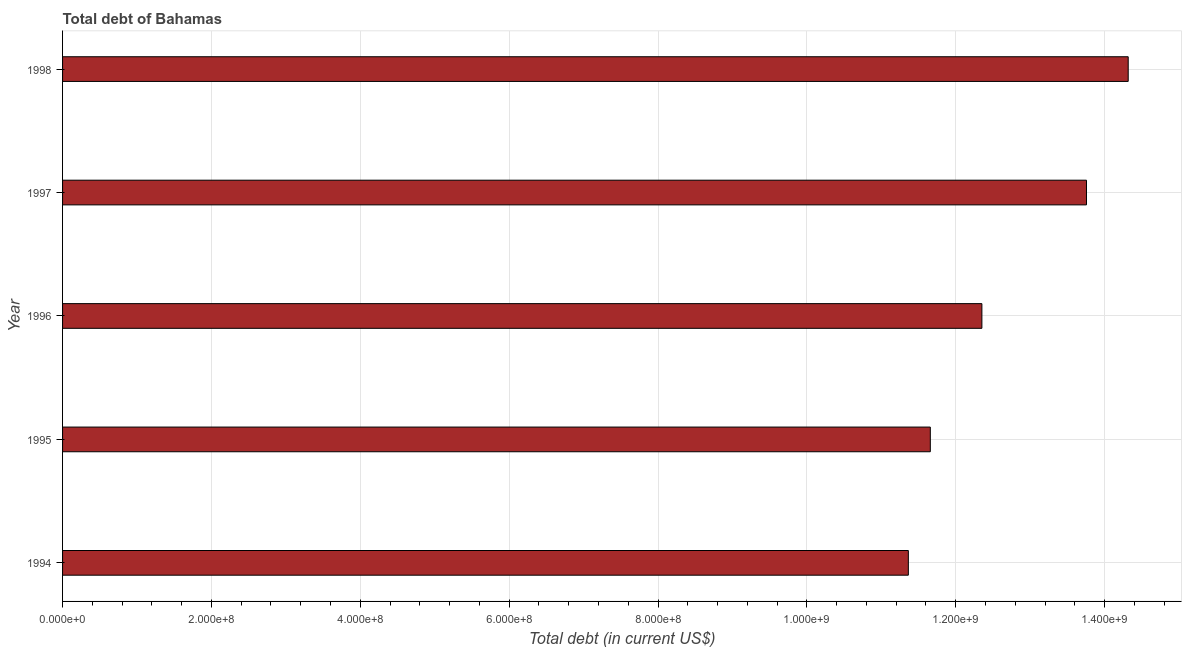What is the title of the graph?
Your response must be concise. Total debt of Bahamas. What is the label or title of the X-axis?
Offer a very short reply. Total debt (in current US$). What is the total debt in 1995?
Make the answer very short. 1.17e+09. Across all years, what is the maximum total debt?
Your answer should be compact. 1.43e+09. Across all years, what is the minimum total debt?
Provide a short and direct response. 1.14e+09. What is the sum of the total debt?
Make the answer very short. 6.34e+09. What is the difference between the total debt in 1994 and 1995?
Offer a terse response. -2.95e+07. What is the average total debt per year?
Offer a very short reply. 1.27e+09. What is the median total debt?
Offer a very short reply. 1.24e+09. What is the ratio of the total debt in 1996 to that in 1998?
Make the answer very short. 0.86. Is the total debt in 1994 less than that in 1998?
Provide a succinct answer. Yes. What is the difference between the highest and the second highest total debt?
Ensure brevity in your answer.  5.60e+07. Is the sum of the total debt in 1995 and 1997 greater than the maximum total debt across all years?
Offer a very short reply. Yes. What is the difference between the highest and the lowest total debt?
Offer a very short reply. 2.95e+08. In how many years, is the total debt greater than the average total debt taken over all years?
Ensure brevity in your answer.  2. How many bars are there?
Your answer should be compact. 5. How many years are there in the graph?
Provide a succinct answer. 5. What is the Total debt (in current US$) in 1994?
Offer a terse response. 1.14e+09. What is the Total debt (in current US$) in 1995?
Ensure brevity in your answer.  1.17e+09. What is the Total debt (in current US$) in 1996?
Give a very brief answer. 1.24e+09. What is the Total debt (in current US$) of 1997?
Ensure brevity in your answer.  1.38e+09. What is the Total debt (in current US$) of 1998?
Give a very brief answer. 1.43e+09. What is the difference between the Total debt (in current US$) in 1994 and 1995?
Make the answer very short. -2.95e+07. What is the difference between the Total debt (in current US$) in 1994 and 1996?
Ensure brevity in your answer.  -9.88e+07. What is the difference between the Total debt (in current US$) in 1994 and 1997?
Offer a terse response. -2.39e+08. What is the difference between the Total debt (in current US$) in 1994 and 1998?
Your response must be concise. -2.95e+08. What is the difference between the Total debt (in current US$) in 1995 and 1996?
Make the answer very short. -6.93e+07. What is the difference between the Total debt (in current US$) in 1995 and 1997?
Provide a succinct answer. -2.10e+08. What is the difference between the Total debt (in current US$) in 1995 and 1998?
Your answer should be very brief. -2.66e+08. What is the difference between the Total debt (in current US$) in 1996 and 1997?
Give a very brief answer. -1.41e+08. What is the difference between the Total debt (in current US$) in 1996 and 1998?
Your answer should be compact. -1.97e+08. What is the difference between the Total debt (in current US$) in 1997 and 1998?
Your response must be concise. -5.60e+07. What is the ratio of the Total debt (in current US$) in 1994 to that in 1995?
Your answer should be very brief. 0.97. What is the ratio of the Total debt (in current US$) in 1994 to that in 1996?
Provide a short and direct response. 0.92. What is the ratio of the Total debt (in current US$) in 1994 to that in 1997?
Your response must be concise. 0.83. What is the ratio of the Total debt (in current US$) in 1994 to that in 1998?
Keep it short and to the point. 0.79. What is the ratio of the Total debt (in current US$) in 1995 to that in 1996?
Your response must be concise. 0.94. What is the ratio of the Total debt (in current US$) in 1995 to that in 1997?
Keep it short and to the point. 0.85. What is the ratio of the Total debt (in current US$) in 1995 to that in 1998?
Offer a terse response. 0.81. What is the ratio of the Total debt (in current US$) in 1996 to that in 1997?
Make the answer very short. 0.9. What is the ratio of the Total debt (in current US$) in 1996 to that in 1998?
Provide a succinct answer. 0.86. What is the ratio of the Total debt (in current US$) in 1997 to that in 1998?
Keep it short and to the point. 0.96. 